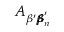<formula> <loc_0><loc_0><loc_500><loc_500>A _ { \beta ^ { \prime } { \pm b \beta } _ { n } ^ { \prime } }</formula> 